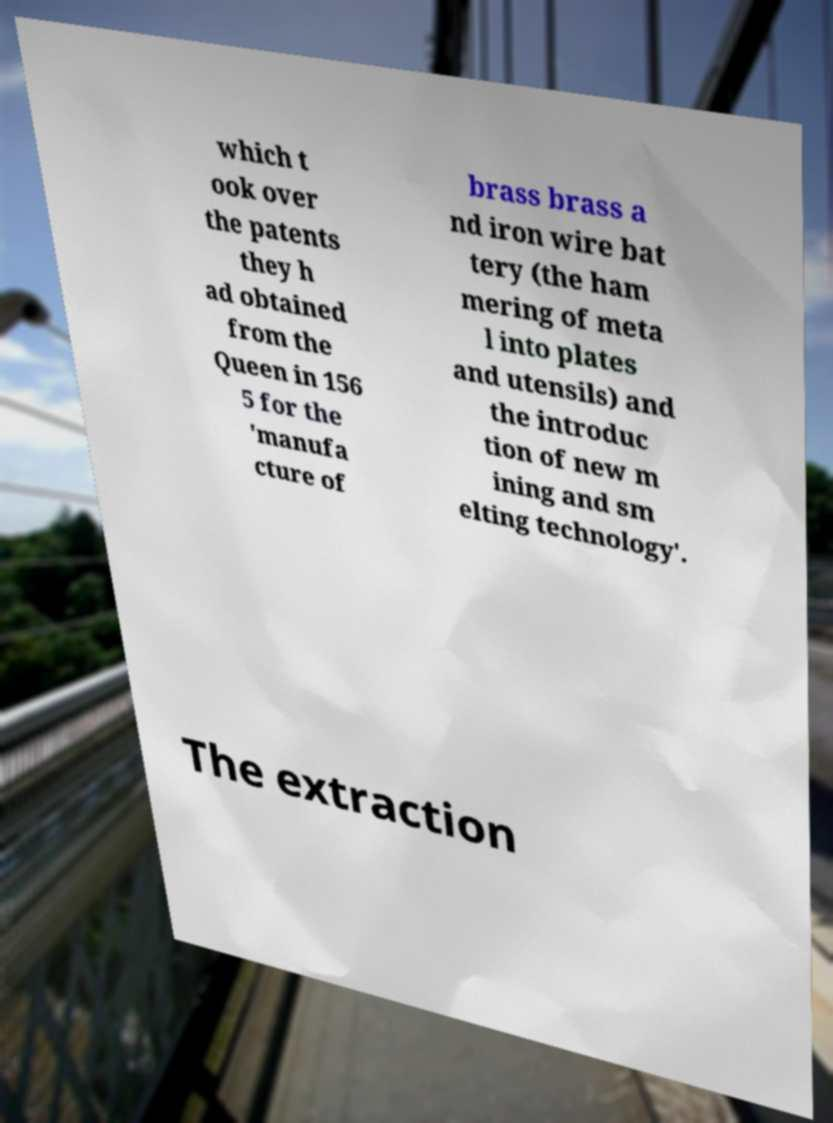Can you accurately transcribe the text from the provided image for me? which t ook over the patents they h ad obtained from the Queen in 156 5 for the 'manufa cture of brass brass a nd iron wire bat tery (the ham mering of meta l into plates and utensils) and the introduc tion of new m ining and sm elting technology'. The extraction 